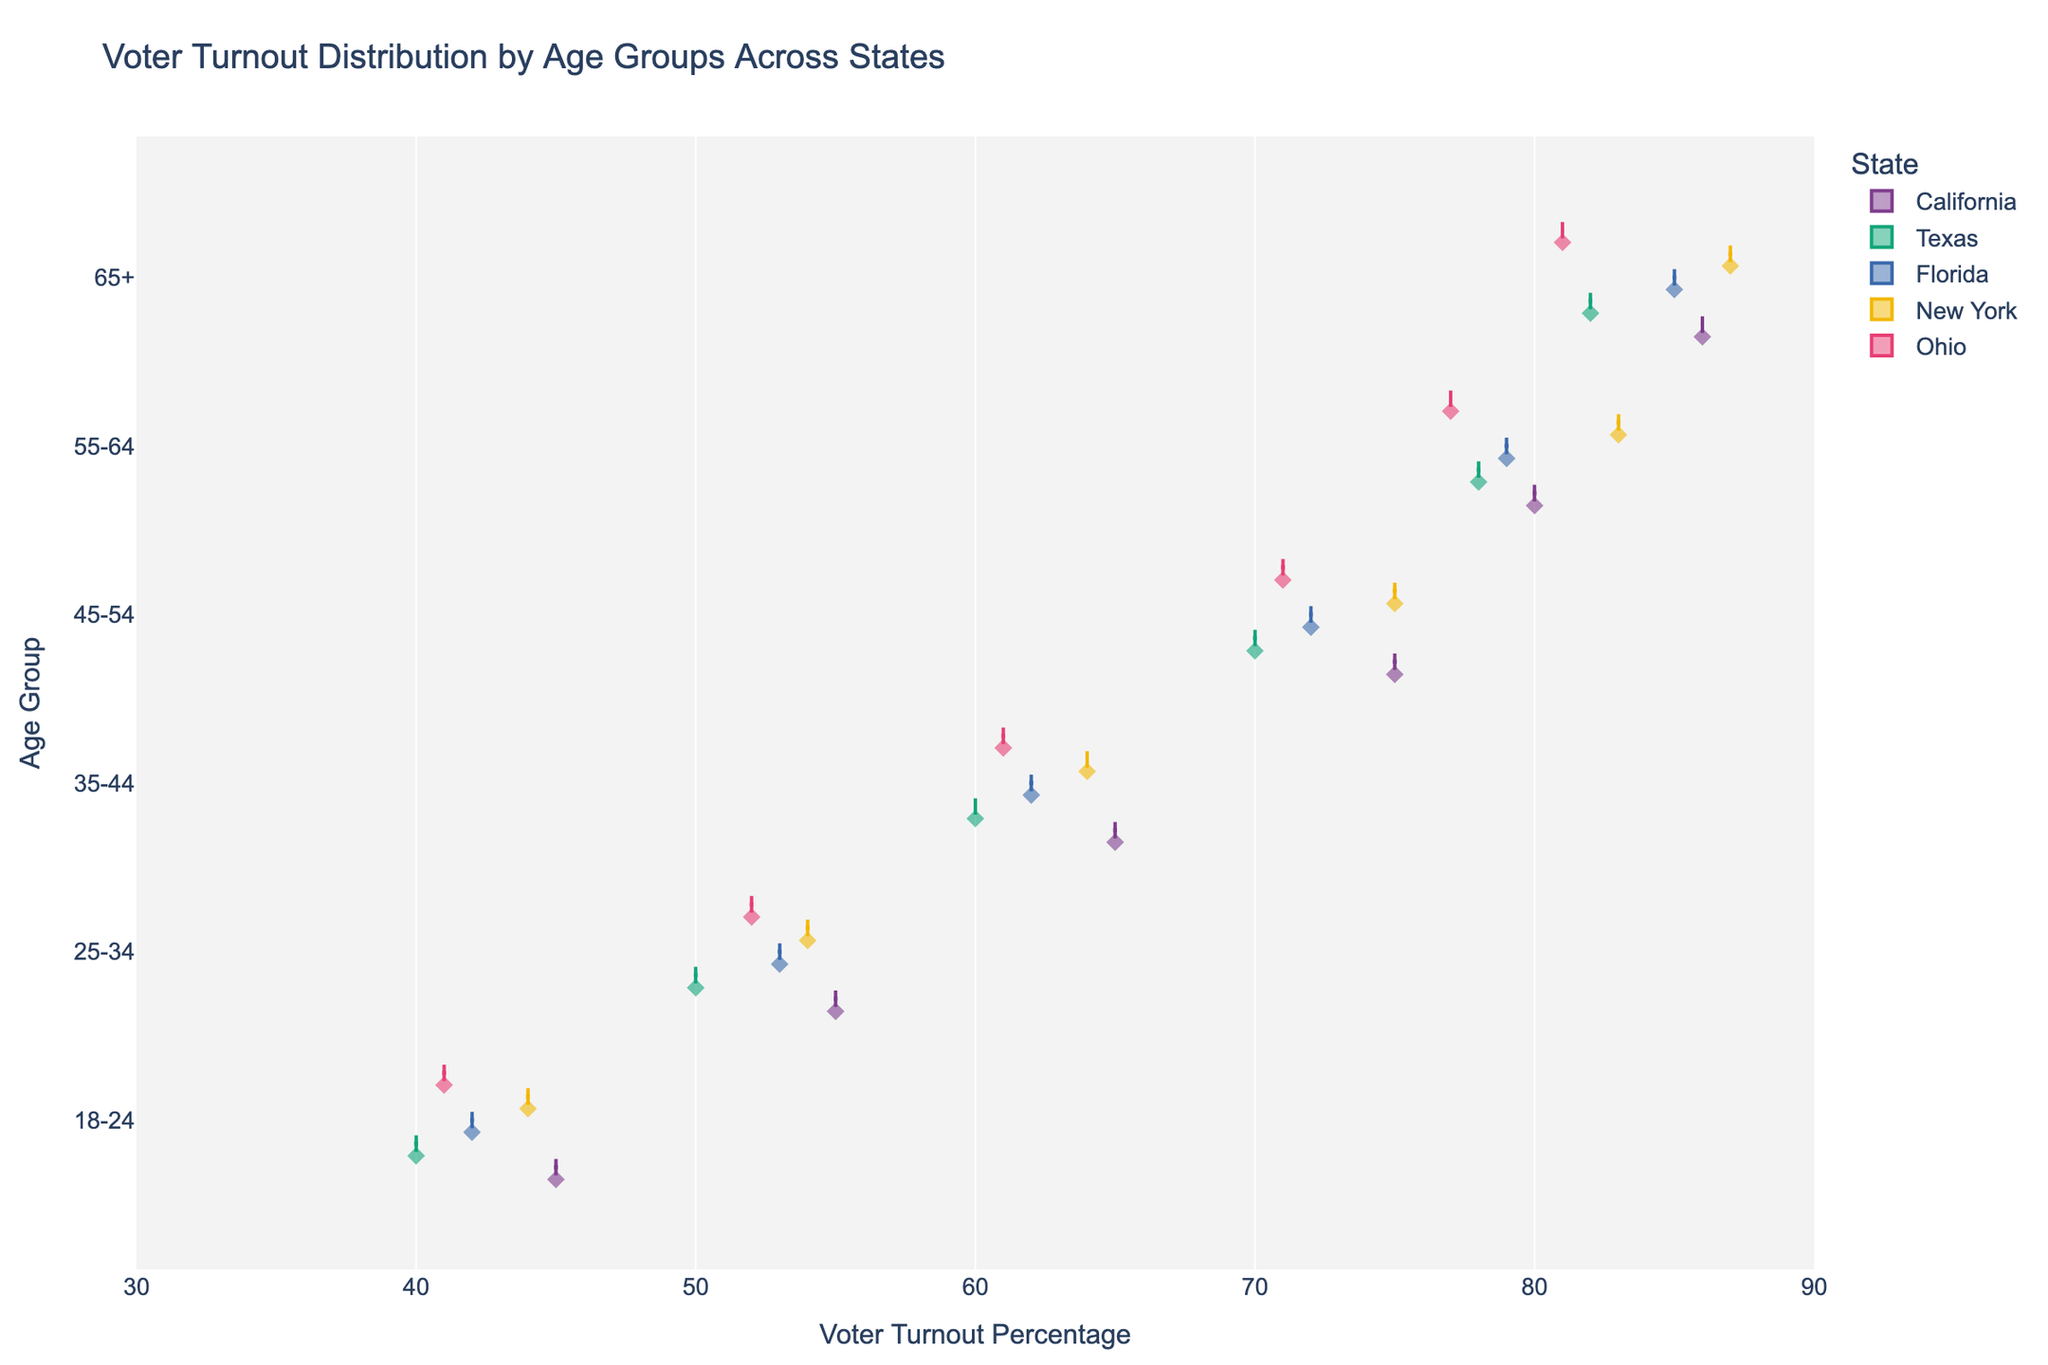What is the title of the plot? The title of the plot is usually found at the top and provides the main summary of the chart. Here, the title is clearly stated.
Answer: Voter Turnout Distribution by Age Groups Across States Which age group has the highest voter turnout percentage in New York? By analyzing the horizontal violins and focusing on New York's colors, the highest turnout percentage for the 65+ age group is evident.
Answer: 65+ What is the voter turnout range for the 18-24 age group in Texas? The horizontal violin for the 18-24 age group in Texas shows the spread of data points from the box plot. The range can be determined by locating the extremes.
Answer: 40-42 Among the 55-64 age group, which state reports the highest voter turnout percentage? By comparing the highest points of the violins for the 55-64 age group among different states, you can identify New York with the highest value.
Answer: New York How does the voter turnout percentage for the 25-34 age group in California compare to that in Florida? By examining the positioning of the horizontal violins for the 25-34 age group in California and Florida, we see California has a slightly higher turnout.
Answer: California is higher Which state has the most variation in voter turnout percentage for the 45-54 age group? Variation is shown by the width and spread of the violin plot. Assessing this for the 45-54 age group, it appears Texas has the widest spread.
Answer: Texas What is the median voter turnout for the 35-44 age group in Ohio? The median can be found by locating the central value of the distribution in the violin plot's box. Check for the data point intersection within Ohio's plot.
Answer: 61 Does the 65+ age group in Florida have a higher turnout percentage than the 55-64 age group in Texas? Compare the rightmost points of the respective violin plots for 65+ in Florida and 55-64 in Texas. The 65+ in Florida reaches further to the right.
Answer: Yes What's the average voter turnout percentage for the 45-54 age group across all states? To determine this, average the voter turnout percentages of the 45-54 age group across the states: (75 + 70 + 72 + 75 + 71) / 5 = 72.6
Answer: 72.6 Which age group shows the smallest range of voter turnout percentages across all states? The smallest range can be found by assessing the spread of each age group's horizontal violins. The 65+ group shows the tightest distribution.
Answer: 65+ 